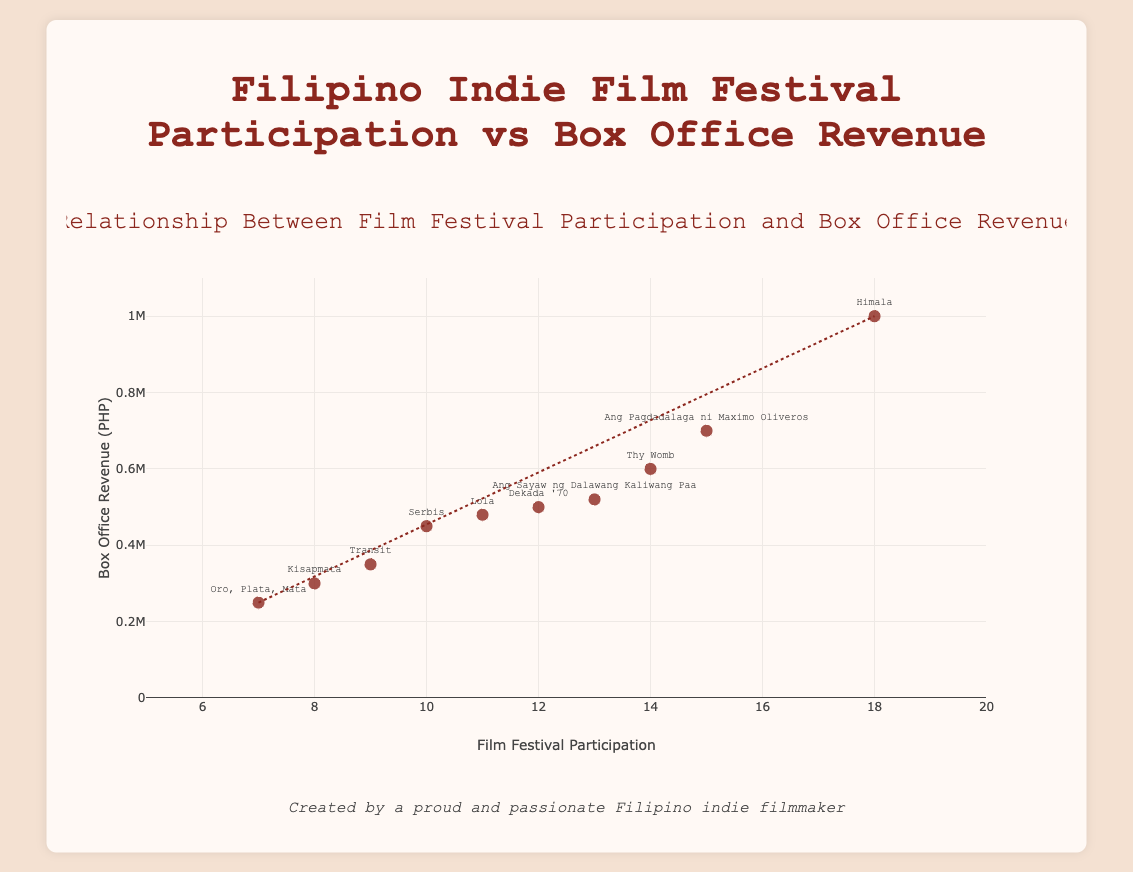What's the title of the figure? The title is prominently displayed at the top of the figure and reads "Relationship Between Film Festival Participation and Box Office Revenue".
Answer: Relationship Between Film Festival Participation and Box Office Revenue How many films are represented in the scatter plot? We can count each data point on the scatter plot. According to the data, there are 10 films represented.
Answer: 10 Which film had the highest box office revenue and what was the amount? The data point with the highest y-axis value represents the highest box office revenue. The film "Himala" had the highest box office revenue at 1,000,000 PHP.
Answer: Himala, 1,000,000 PHP What is the trend line suggesting about the relationship between festival participation and box office revenue? The trend line, which usually represents the general direction of the data points, suggests that as festival participation increases, box office revenue tends to increase as well. This upward trend line corroborates a positive correlation.
Answer: Positive correlation Which film had the least festival participation and how much was its box office revenue? The film with the lowest x-axis value represents the least festival participation. "Oro, Plata, Mata" had the least festival participation with 7 and its box office revenue was 250,000 PHP.
Answer: Oro, Plata, Mata, 250,000 PHP What is the average box office revenue of the films? Summing up all the box office revenues: 700,000 + 300,000 + 500,000 + 1,000,000 + 450,000 + 250,000 + 600,000 + 480,000 + 350,000 + 520,000 = 5,150,000 PHP. Then, divide by the number of films (10): 5,150,000 / 10 = 515,000 PHP.
Answer: 515,000 PHP Which films had a box office revenue greater than the average box office revenue? First, calculate the average box office revenue (515,000 PHP). Then identify the films exceeding this value: "Ang Pagdadalaga ni Maximo Oliveros", "Himala", "Thy Womb", and "Ang Sayaw ng Dalawang Kaliwang Paa".
Answer: Ang Pagdadalaga ni Maximo Oliveros, Himala, Thy Womb, Ang Sayaw ng Dalawang Kaliwang Paa Is there an outlier in terms of box office revenue? If yes, which one? An outlier in this context would be a data point that significantly deviates from the general trend. "Himala", with a box office revenue of 1,000,000 PHP, stands out considerably from the rest.
Answer: Himala Which film had the closest box office revenue to the trend line at 15 festival participations? By looking at the data point closest to the trend line at the 15 festival participations mark, "Ang Pagdadalaga ni Maximo Oliveros" is the film closest to the trend line with a box office revenue of 700,000 PHP.
Answer: Ang Pagdadalaga ni Maximo Oliveros 